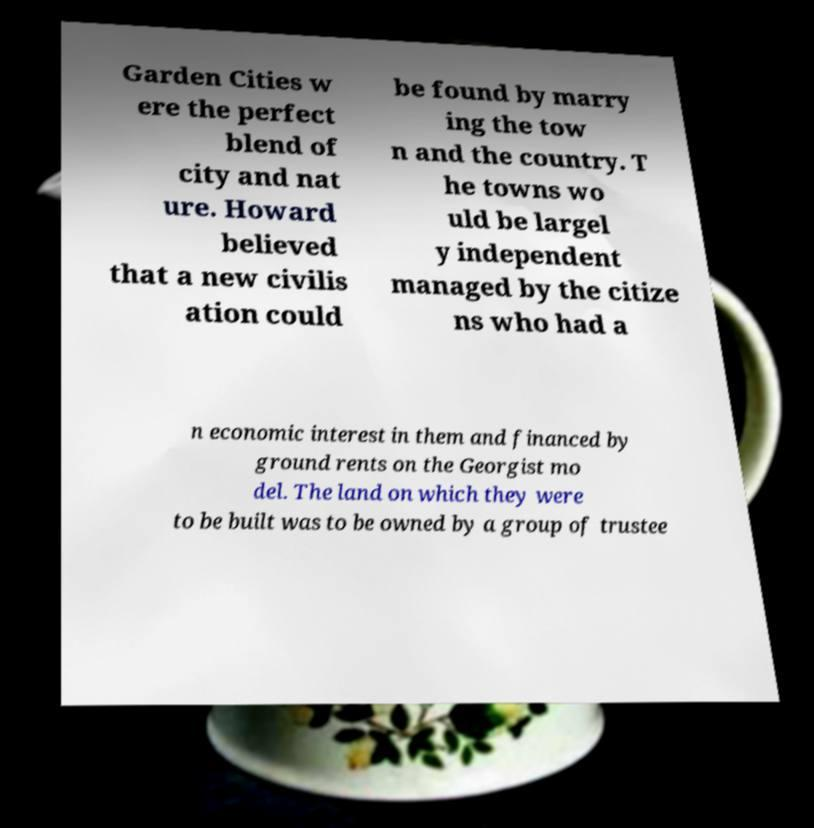Please identify and transcribe the text found in this image. Garden Cities w ere the perfect blend of city and nat ure. Howard believed that a new civilis ation could be found by marry ing the tow n and the country. T he towns wo uld be largel y independent managed by the citize ns who had a n economic interest in them and financed by ground rents on the Georgist mo del. The land on which they were to be built was to be owned by a group of trustee 